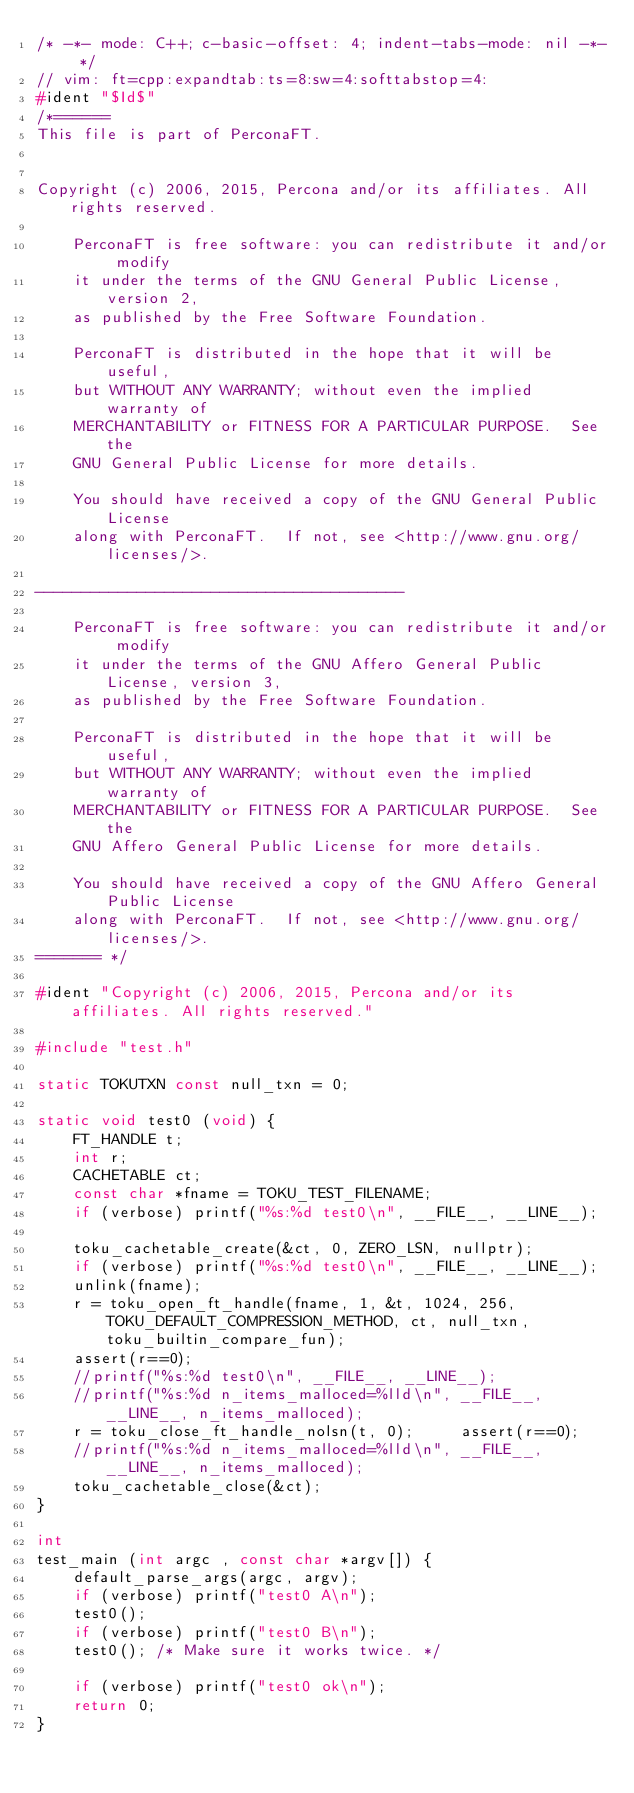<code> <loc_0><loc_0><loc_500><loc_500><_C++_>/* -*- mode: C++; c-basic-offset: 4; indent-tabs-mode: nil -*- */
// vim: ft=cpp:expandtab:ts=8:sw=4:softtabstop=4:
#ident "$Id$"
/*======
This file is part of PerconaFT.


Copyright (c) 2006, 2015, Percona and/or its affiliates. All rights reserved.

    PerconaFT is free software: you can redistribute it and/or modify
    it under the terms of the GNU General Public License, version 2,
    as published by the Free Software Foundation.

    PerconaFT is distributed in the hope that it will be useful,
    but WITHOUT ANY WARRANTY; without even the implied warranty of
    MERCHANTABILITY or FITNESS FOR A PARTICULAR PURPOSE.  See the
    GNU General Public License for more details.

    You should have received a copy of the GNU General Public License
    along with PerconaFT.  If not, see <http://www.gnu.org/licenses/>.

----------------------------------------

    PerconaFT is free software: you can redistribute it and/or modify
    it under the terms of the GNU Affero General Public License, version 3,
    as published by the Free Software Foundation.

    PerconaFT is distributed in the hope that it will be useful,
    but WITHOUT ANY WARRANTY; without even the implied warranty of
    MERCHANTABILITY or FITNESS FOR A PARTICULAR PURPOSE.  See the
    GNU Affero General Public License for more details.

    You should have received a copy of the GNU Affero General Public License
    along with PerconaFT.  If not, see <http://www.gnu.org/licenses/>.
======= */

#ident "Copyright (c) 2006, 2015, Percona and/or its affiliates. All rights reserved."

#include "test.h"

static TOKUTXN const null_txn = 0;

static void test0 (void) {
    FT_HANDLE t;
    int r;
    CACHETABLE ct;
    const char *fname = TOKU_TEST_FILENAME;
    if (verbose) printf("%s:%d test0\n", __FILE__, __LINE__);
    
    toku_cachetable_create(&ct, 0, ZERO_LSN, nullptr);
    if (verbose) printf("%s:%d test0\n", __FILE__, __LINE__);
    unlink(fname);
    r = toku_open_ft_handle(fname, 1, &t, 1024, 256, TOKU_DEFAULT_COMPRESSION_METHOD, ct, null_txn, toku_builtin_compare_fun);
    assert(r==0);
    //printf("%s:%d test0\n", __FILE__, __LINE__);
    //printf("%s:%d n_items_malloced=%lld\n", __FILE__, __LINE__, n_items_malloced);
    r = toku_close_ft_handle_nolsn(t, 0);     assert(r==0);
    //printf("%s:%d n_items_malloced=%lld\n", __FILE__, __LINE__, n_items_malloced);
    toku_cachetable_close(&ct);
}

int
test_main (int argc , const char *argv[]) {
    default_parse_args(argc, argv);
    if (verbose) printf("test0 A\n");
    test0();
    if (verbose) printf("test0 B\n");
    test0(); /* Make sure it works twice. */
    
    if (verbose) printf("test0 ok\n");
    return 0;
}
</code> 